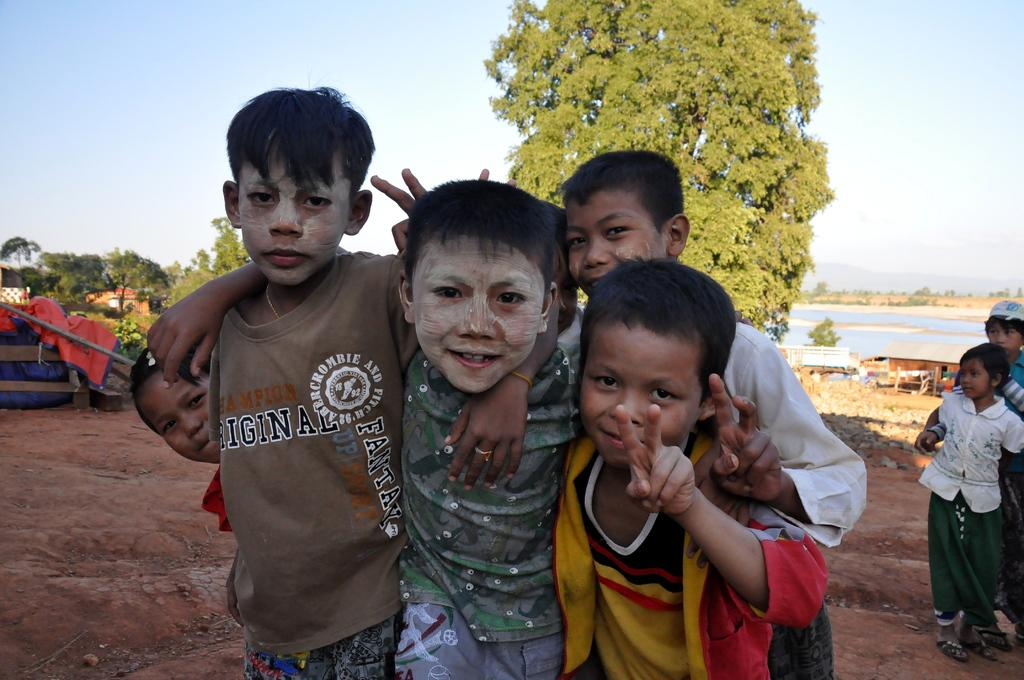What are the main subjects in the image? Children are standing in the image. What can be seen in the background of the image? There are trees, other people, benches, sheds, and water visible in the background of the image. How many loaves of bread are being requested by the children in the image? There is no mention of bread or any request in the image; the children are simply standing. Can you see any snakes in the image? There are no snakes visible in the image. 